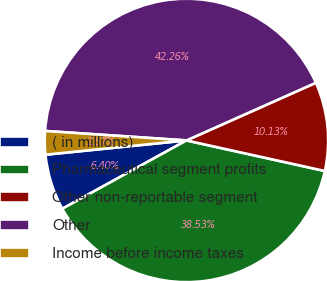Convert chart. <chart><loc_0><loc_0><loc_500><loc_500><pie_chart><fcel>( in millions)<fcel>Pharmaceutical segment profits<fcel>Other non-reportable segment<fcel>Other<fcel>Income before income taxes<nl><fcel>6.4%<fcel>38.53%<fcel>10.13%<fcel>42.26%<fcel>2.67%<nl></chart> 